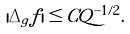Convert formula to latex. <formula><loc_0><loc_0><loc_500><loc_500>| \Delta _ { g } f | \leq C Q ^ { - 1 / 2 } .</formula> 